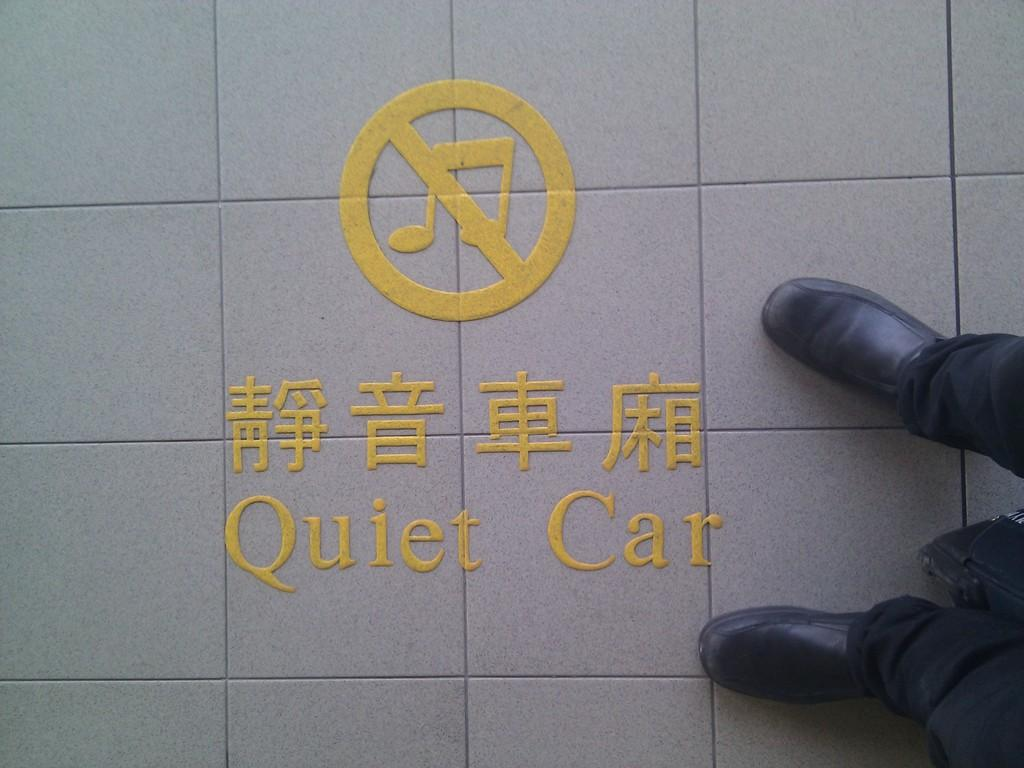What is the main subject of the image? There is a man in the image. What type of shoes is the man wearing? The man is wearing black shoes. What type of pants is the man wearing? The man is wearing black pants. Where is the man standing in the image? The man is standing on the floor. What can be seen on the floor in the image? There is text on the floor. What type of drawer is visible in the image? There is no drawer present in the image; it features a man standing on the floor with text on it. 